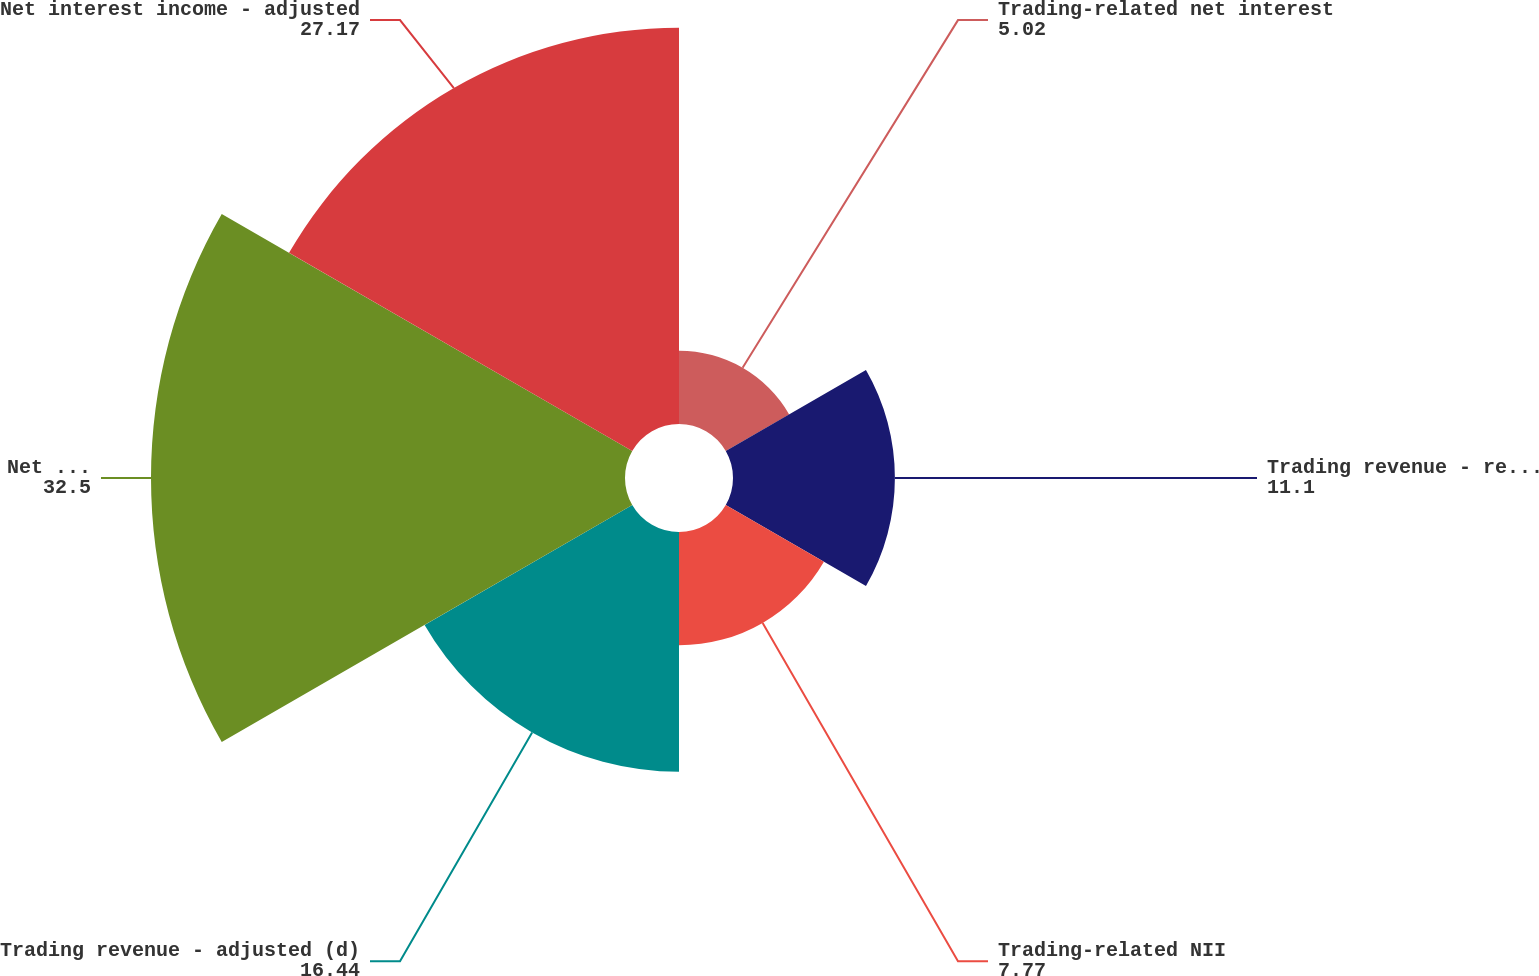<chart> <loc_0><loc_0><loc_500><loc_500><pie_chart><fcel>Trading-related net interest<fcel>Trading revenue - reported (d)<fcel>Trading-related NII<fcel>Trading revenue - adjusted (d)<fcel>Net interest income - reported<fcel>Net interest income - adjusted<nl><fcel>5.02%<fcel>11.1%<fcel>7.77%<fcel>16.44%<fcel>32.5%<fcel>27.17%<nl></chart> 